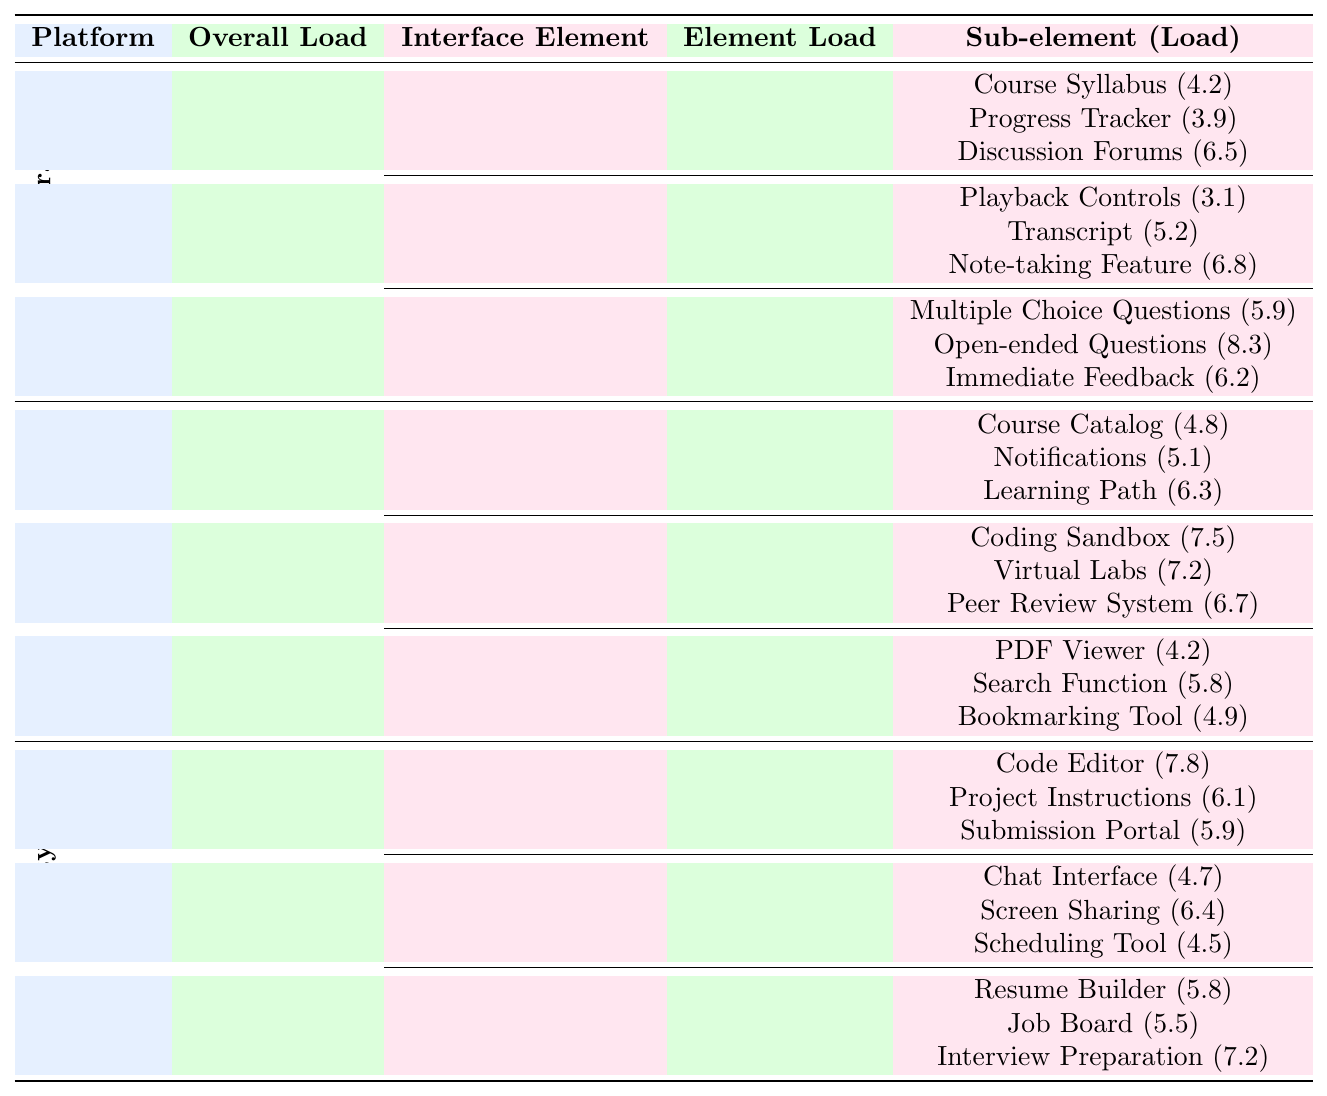What is the overall cognitive load for the Coursera platform? The overall cognitive load for Coursera is listed directly in the table under the respective column. It shows a value of 6.2.
Answer: 6.2 Which interface element has the highest cognitive load on Udacity? The table shows that under Udacity, the Project Workspace has the highest cognitive load of 7.3.
Answer: Project Workspace What is the cognitive load of the Discussion Forums under the Course Navigation element in Coursera? By looking at the table, the Discussion Forums are listed under Course Navigation in Coursera, with a cognitive load of 6.5.
Answer: 6.5 Is the cognitive load for the Coding Sandbox in edX higher than that for the Quiz Interface in Coursera? The Coding Sandbox has a cognitive load of 7.5 while the Quiz Interface in Coursera has a cognitive load of 7.1, thus 7.5 > 7.1, making the statement true.
Answer: Yes What is the average cognitive load of the sub-elements under the Video Player in Coursera? The sub-elements are Playback Controls (3.1), Transcript (5.2), and Note-taking Feature (6.8). Adding these gives 3.1 + 5.2 + 6.8 = 15.1. To find the average, divide by 3: 15.1 / 3 = 5.03.
Answer: 5.03 Which e-learning platform has the lowest overall cognitive load? Reviewing the overall cognitive loads, Coursera (6.2), edX (5.9), and Udacity (6.5) show that edX has the lowest value of 5.9.
Answer: edX How does the cognitive load of the Progress Tracker compare to that of the Search Function in edX? The Progress Tracker from Coursera has a cognitive load of 3.9 and the Search Function in edX has a load of 5.8. Comparing these values shows that 3.9 < 5.8.
Answer: Progress Tracker is lower Which interface element in edX has the highest total cognitive load when considering its sub-elements? The Interactive Exercises element has sub-elements with loads of 7.5, 7.2, and 6.7, which when summed up gives 7.5 + 7.2 + 6.7 = 21.4, higher than others.
Answer: Interactive Exercises If the total load for each e-learning platform was scaled between 0 to 10, where would Udacity's Project Workspace fall? Since the load for Project Workspace is 7.3 out of a maximum of 10, it would be represented as 7.3 on a 0 to 10 scale.
Answer: 7.3 What is the difference in cognitive load between the highest and lowest sub-elements of the Career Resources section in Udacity? The sub-elements are Resume Builder (5.8), Job Board (5.5), and Interview Preparation (7.2). The highest is 7.2 and the lowest is 5.5. The difference is 7.2 - 5.5 = 1.7.
Answer: 1.7 